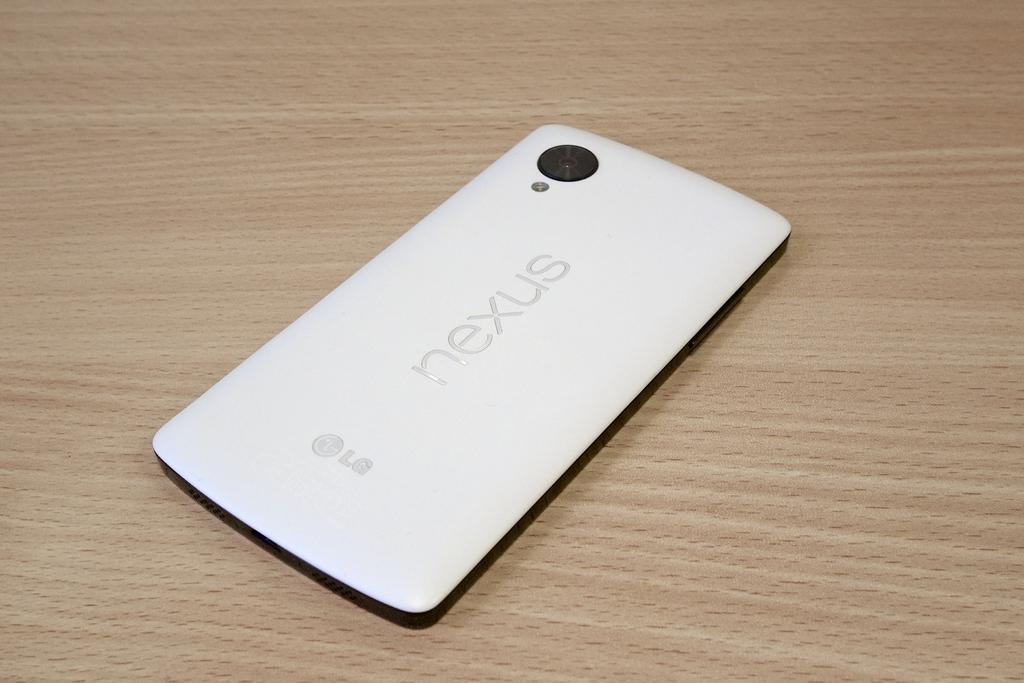<image>
Render a clear and concise summary of the photo. A white LG Nexus phone is on a wooden table. 